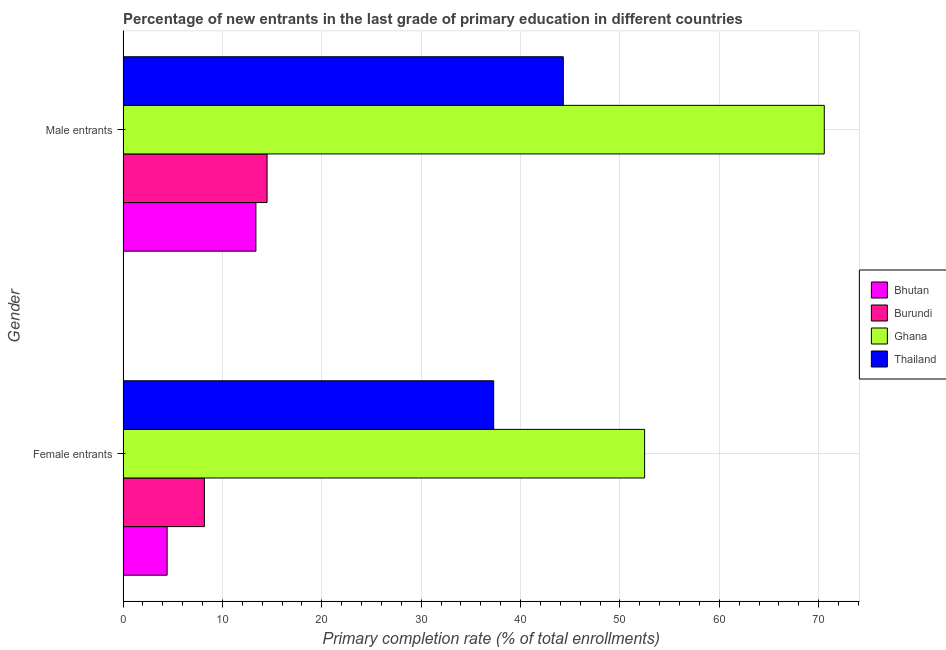How many bars are there on the 2nd tick from the bottom?
Make the answer very short. 4. What is the label of the 1st group of bars from the top?
Provide a succinct answer. Male entrants. What is the primary completion rate of female entrants in Thailand?
Ensure brevity in your answer.  37.3. Across all countries, what is the maximum primary completion rate of female entrants?
Keep it short and to the point. 52.49. Across all countries, what is the minimum primary completion rate of female entrants?
Your answer should be compact. 4.44. In which country was the primary completion rate of male entrants maximum?
Ensure brevity in your answer.  Ghana. In which country was the primary completion rate of female entrants minimum?
Provide a short and direct response. Bhutan. What is the total primary completion rate of female entrants in the graph?
Provide a short and direct response. 102.41. What is the difference between the primary completion rate of female entrants in Bhutan and that in Thailand?
Keep it short and to the point. -32.86. What is the difference between the primary completion rate of female entrants in Burundi and the primary completion rate of male entrants in Thailand?
Give a very brief answer. -36.12. What is the average primary completion rate of male entrants per country?
Your response must be concise. 35.69. What is the difference between the primary completion rate of male entrants and primary completion rate of female entrants in Bhutan?
Give a very brief answer. 8.93. In how many countries, is the primary completion rate of male entrants greater than 32 %?
Provide a succinct answer. 2. What is the ratio of the primary completion rate of male entrants in Bhutan to that in Burundi?
Give a very brief answer. 0.92. Is the primary completion rate of female entrants in Ghana less than that in Bhutan?
Your response must be concise. No. What does the 4th bar from the top in Female entrants represents?
Give a very brief answer. Bhutan. What does the 2nd bar from the bottom in Male entrants represents?
Your answer should be compact. Burundi. How many bars are there?
Provide a succinct answer. 8. Are all the bars in the graph horizontal?
Provide a short and direct response. Yes. How many countries are there in the graph?
Provide a succinct answer. 4. Does the graph contain any zero values?
Make the answer very short. No. Does the graph contain grids?
Offer a terse response. Yes. What is the title of the graph?
Ensure brevity in your answer.  Percentage of new entrants in the last grade of primary education in different countries. Does "Costa Rica" appear as one of the legend labels in the graph?
Offer a terse response. No. What is the label or title of the X-axis?
Provide a short and direct response. Primary completion rate (% of total enrollments). What is the label or title of the Y-axis?
Ensure brevity in your answer.  Gender. What is the Primary completion rate (% of total enrollments) in Bhutan in Female entrants?
Your answer should be compact. 4.44. What is the Primary completion rate (% of total enrollments) of Burundi in Female entrants?
Ensure brevity in your answer.  8.19. What is the Primary completion rate (% of total enrollments) of Ghana in Female entrants?
Your response must be concise. 52.49. What is the Primary completion rate (% of total enrollments) in Thailand in Female entrants?
Ensure brevity in your answer.  37.3. What is the Primary completion rate (% of total enrollments) in Bhutan in Male entrants?
Give a very brief answer. 13.37. What is the Primary completion rate (% of total enrollments) of Burundi in Male entrants?
Make the answer very short. 14.5. What is the Primary completion rate (% of total enrollments) of Ghana in Male entrants?
Keep it short and to the point. 70.56. What is the Primary completion rate (% of total enrollments) in Thailand in Male entrants?
Your answer should be compact. 44.3. Across all Gender, what is the maximum Primary completion rate (% of total enrollments) of Bhutan?
Provide a short and direct response. 13.37. Across all Gender, what is the maximum Primary completion rate (% of total enrollments) in Burundi?
Make the answer very short. 14.5. Across all Gender, what is the maximum Primary completion rate (% of total enrollments) in Ghana?
Your answer should be very brief. 70.56. Across all Gender, what is the maximum Primary completion rate (% of total enrollments) in Thailand?
Offer a very short reply. 44.3. Across all Gender, what is the minimum Primary completion rate (% of total enrollments) in Bhutan?
Provide a short and direct response. 4.44. Across all Gender, what is the minimum Primary completion rate (% of total enrollments) of Burundi?
Keep it short and to the point. 8.19. Across all Gender, what is the minimum Primary completion rate (% of total enrollments) in Ghana?
Offer a very short reply. 52.49. Across all Gender, what is the minimum Primary completion rate (% of total enrollments) in Thailand?
Your answer should be compact. 37.3. What is the total Primary completion rate (% of total enrollments) of Bhutan in the graph?
Your answer should be very brief. 17.81. What is the total Primary completion rate (% of total enrollments) of Burundi in the graph?
Provide a short and direct response. 22.68. What is the total Primary completion rate (% of total enrollments) of Ghana in the graph?
Ensure brevity in your answer.  123.05. What is the total Primary completion rate (% of total enrollments) in Thailand in the graph?
Your response must be concise. 81.6. What is the difference between the Primary completion rate (% of total enrollments) in Bhutan in Female entrants and that in Male entrants?
Your answer should be very brief. -8.93. What is the difference between the Primary completion rate (% of total enrollments) of Burundi in Female entrants and that in Male entrants?
Ensure brevity in your answer.  -6.31. What is the difference between the Primary completion rate (% of total enrollments) in Ghana in Female entrants and that in Male entrants?
Your answer should be very brief. -18.08. What is the difference between the Primary completion rate (% of total enrollments) in Thailand in Female entrants and that in Male entrants?
Make the answer very short. -7.01. What is the difference between the Primary completion rate (% of total enrollments) in Bhutan in Female entrants and the Primary completion rate (% of total enrollments) in Burundi in Male entrants?
Keep it short and to the point. -10.06. What is the difference between the Primary completion rate (% of total enrollments) in Bhutan in Female entrants and the Primary completion rate (% of total enrollments) in Ghana in Male entrants?
Your response must be concise. -66.12. What is the difference between the Primary completion rate (% of total enrollments) of Bhutan in Female entrants and the Primary completion rate (% of total enrollments) of Thailand in Male entrants?
Give a very brief answer. -39.86. What is the difference between the Primary completion rate (% of total enrollments) of Burundi in Female entrants and the Primary completion rate (% of total enrollments) of Ghana in Male entrants?
Your response must be concise. -62.38. What is the difference between the Primary completion rate (% of total enrollments) of Burundi in Female entrants and the Primary completion rate (% of total enrollments) of Thailand in Male entrants?
Offer a very short reply. -36.12. What is the difference between the Primary completion rate (% of total enrollments) of Ghana in Female entrants and the Primary completion rate (% of total enrollments) of Thailand in Male entrants?
Give a very brief answer. 8.18. What is the average Primary completion rate (% of total enrollments) of Bhutan per Gender?
Make the answer very short. 8.91. What is the average Primary completion rate (% of total enrollments) of Burundi per Gender?
Make the answer very short. 11.34. What is the average Primary completion rate (% of total enrollments) of Ghana per Gender?
Your answer should be very brief. 61.53. What is the average Primary completion rate (% of total enrollments) in Thailand per Gender?
Provide a short and direct response. 40.8. What is the difference between the Primary completion rate (% of total enrollments) in Bhutan and Primary completion rate (% of total enrollments) in Burundi in Female entrants?
Your answer should be very brief. -3.75. What is the difference between the Primary completion rate (% of total enrollments) of Bhutan and Primary completion rate (% of total enrollments) of Ghana in Female entrants?
Make the answer very short. -48.05. What is the difference between the Primary completion rate (% of total enrollments) in Bhutan and Primary completion rate (% of total enrollments) in Thailand in Female entrants?
Your answer should be very brief. -32.86. What is the difference between the Primary completion rate (% of total enrollments) in Burundi and Primary completion rate (% of total enrollments) in Ghana in Female entrants?
Make the answer very short. -44.3. What is the difference between the Primary completion rate (% of total enrollments) of Burundi and Primary completion rate (% of total enrollments) of Thailand in Female entrants?
Give a very brief answer. -29.11. What is the difference between the Primary completion rate (% of total enrollments) of Ghana and Primary completion rate (% of total enrollments) of Thailand in Female entrants?
Your answer should be compact. 15.19. What is the difference between the Primary completion rate (% of total enrollments) in Bhutan and Primary completion rate (% of total enrollments) in Burundi in Male entrants?
Offer a terse response. -1.12. What is the difference between the Primary completion rate (% of total enrollments) of Bhutan and Primary completion rate (% of total enrollments) of Ghana in Male entrants?
Offer a terse response. -57.19. What is the difference between the Primary completion rate (% of total enrollments) of Bhutan and Primary completion rate (% of total enrollments) of Thailand in Male entrants?
Make the answer very short. -30.93. What is the difference between the Primary completion rate (% of total enrollments) in Burundi and Primary completion rate (% of total enrollments) in Ghana in Male entrants?
Provide a short and direct response. -56.07. What is the difference between the Primary completion rate (% of total enrollments) in Burundi and Primary completion rate (% of total enrollments) in Thailand in Male entrants?
Offer a terse response. -29.81. What is the difference between the Primary completion rate (% of total enrollments) of Ghana and Primary completion rate (% of total enrollments) of Thailand in Male entrants?
Give a very brief answer. 26.26. What is the ratio of the Primary completion rate (% of total enrollments) in Bhutan in Female entrants to that in Male entrants?
Provide a succinct answer. 0.33. What is the ratio of the Primary completion rate (% of total enrollments) of Burundi in Female entrants to that in Male entrants?
Make the answer very short. 0.56. What is the ratio of the Primary completion rate (% of total enrollments) of Ghana in Female entrants to that in Male entrants?
Provide a succinct answer. 0.74. What is the ratio of the Primary completion rate (% of total enrollments) of Thailand in Female entrants to that in Male entrants?
Make the answer very short. 0.84. What is the difference between the highest and the second highest Primary completion rate (% of total enrollments) in Bhutan?
Keep it short and to the point. 8.93. What is the difference between the highest and the second highest Primary completion rate (% of total enrollments) of Burundi?
Make the answer very short. 6.31. What is the difference between the highest and the second highest Primary completion rate (% of total enrollments) in Ghana?
Give a very brief answer. 18.08. What is the difference between the highest and the second highest Primary completion rate (% of total enrollments) in Thailand?
Provide a succinct answer. 7.01. What is the difference between the highest and the lowest Primary completion rate (% of total enrollments) of Bhutan?
Your answer should be compact. 8.93. What is the difference between the highest and the lowest Primary completion rate (% of total enrollments) in Burundi?
Keep it short and to the point. 6.31. What is the difference between the highest and the lowest Primary completion rate (% of total enrollments) in Ghana?
Offer a terse response. 18.08. What is the difference between the highest and the lowest Primary completion rate (% of total enrollments) of Thailand?
Your response must be concise. 7.01. 